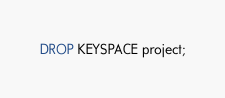<code> <loc_0><loc_0><loc_500><loc_500><_SQL_>DROP KEYSPACE project;</code> 